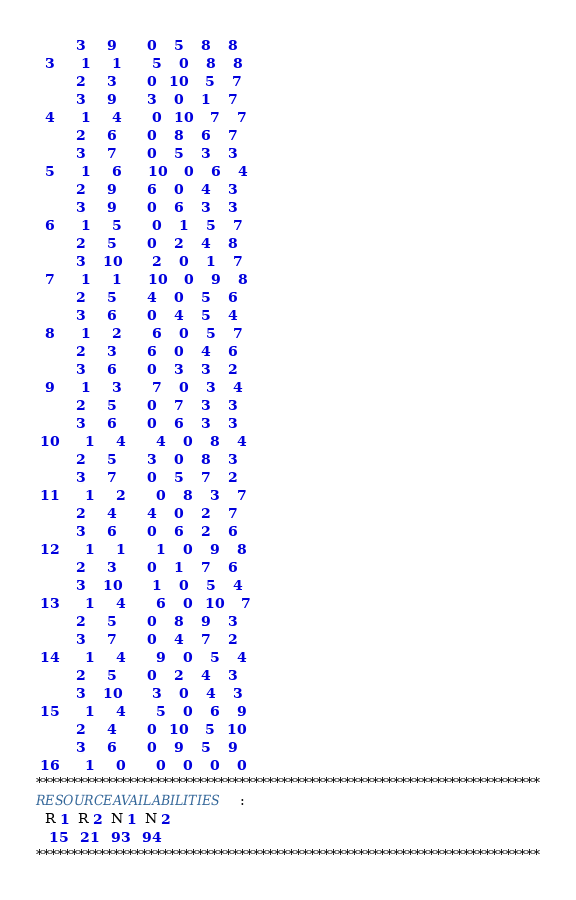<code> <loc_0><loc_0><loc_500><loc_500><_ObjectiveC_>         3     9       0    5    8    8
  3      1     1       5    0    8    8
         2     3       0   10    5    7
         3     9       3    0    1    7
  4      1     4       0   10    7    7
         2     6       0    8    6    7
         3     7       0    5    3    3
  5      1     6      10    0    6    4
         2     9       6    0    4    3
         3     9       0    6    3    3
  6      1     5       0    1    5    7
         2     5       0    2    4    8
         3    10       2    0    1    7
  7      1     1      10    0    9    8
         2     5       4    0    5    6
         3     6       0    4    5    4
  8      1     2       6    0    5    7
         2     3       6    0    4    6
         3     6       0    3    3    2
  9      1     3       7    0    3    4
         2     5       0    7    3    3
         3     6       0    6    3    3
 10      1     4       4    0    8    4
         2     5       3    0    8    3
         3     7       0    5    7    2
 11      1     2       0    8    3    7
         2     4       4    0    2    7
         3     6       0    6    2    6
 12      1     1       1    0    9    8
         2     3       0    1    7    6
         3    10       1    0    5    4
 13      1     4       6    0   10    7
         2     5       0    8    9    3
         3     7       0    4    7    2
 14      1     4       9    0    5    4
         2     5       0    2    4    3
         3    10       3    0    4    3
 15      1     4       5    0    6    9
         2     4       0   10    5   10
         3     6       0    9    5    9
 16      1     0       0    0    0    0
************************************************************************
RESOURCEAVAILABILITIES:
  R 1  R 2  N 1  N 2
   15   21   93   94
************************************************************************
</code> 